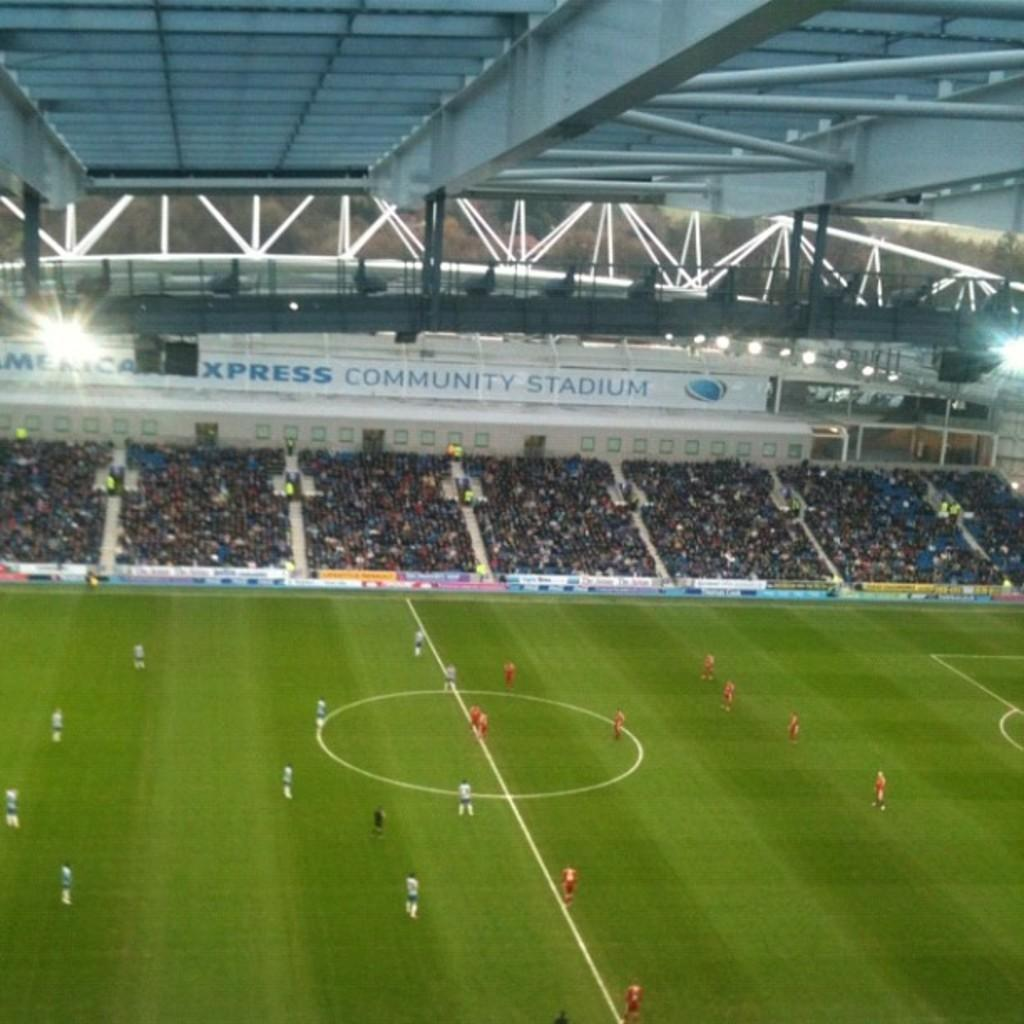<image>
Summarize the visual content of the image. Soccer players set to begin a match at American Express Community Stadium. 